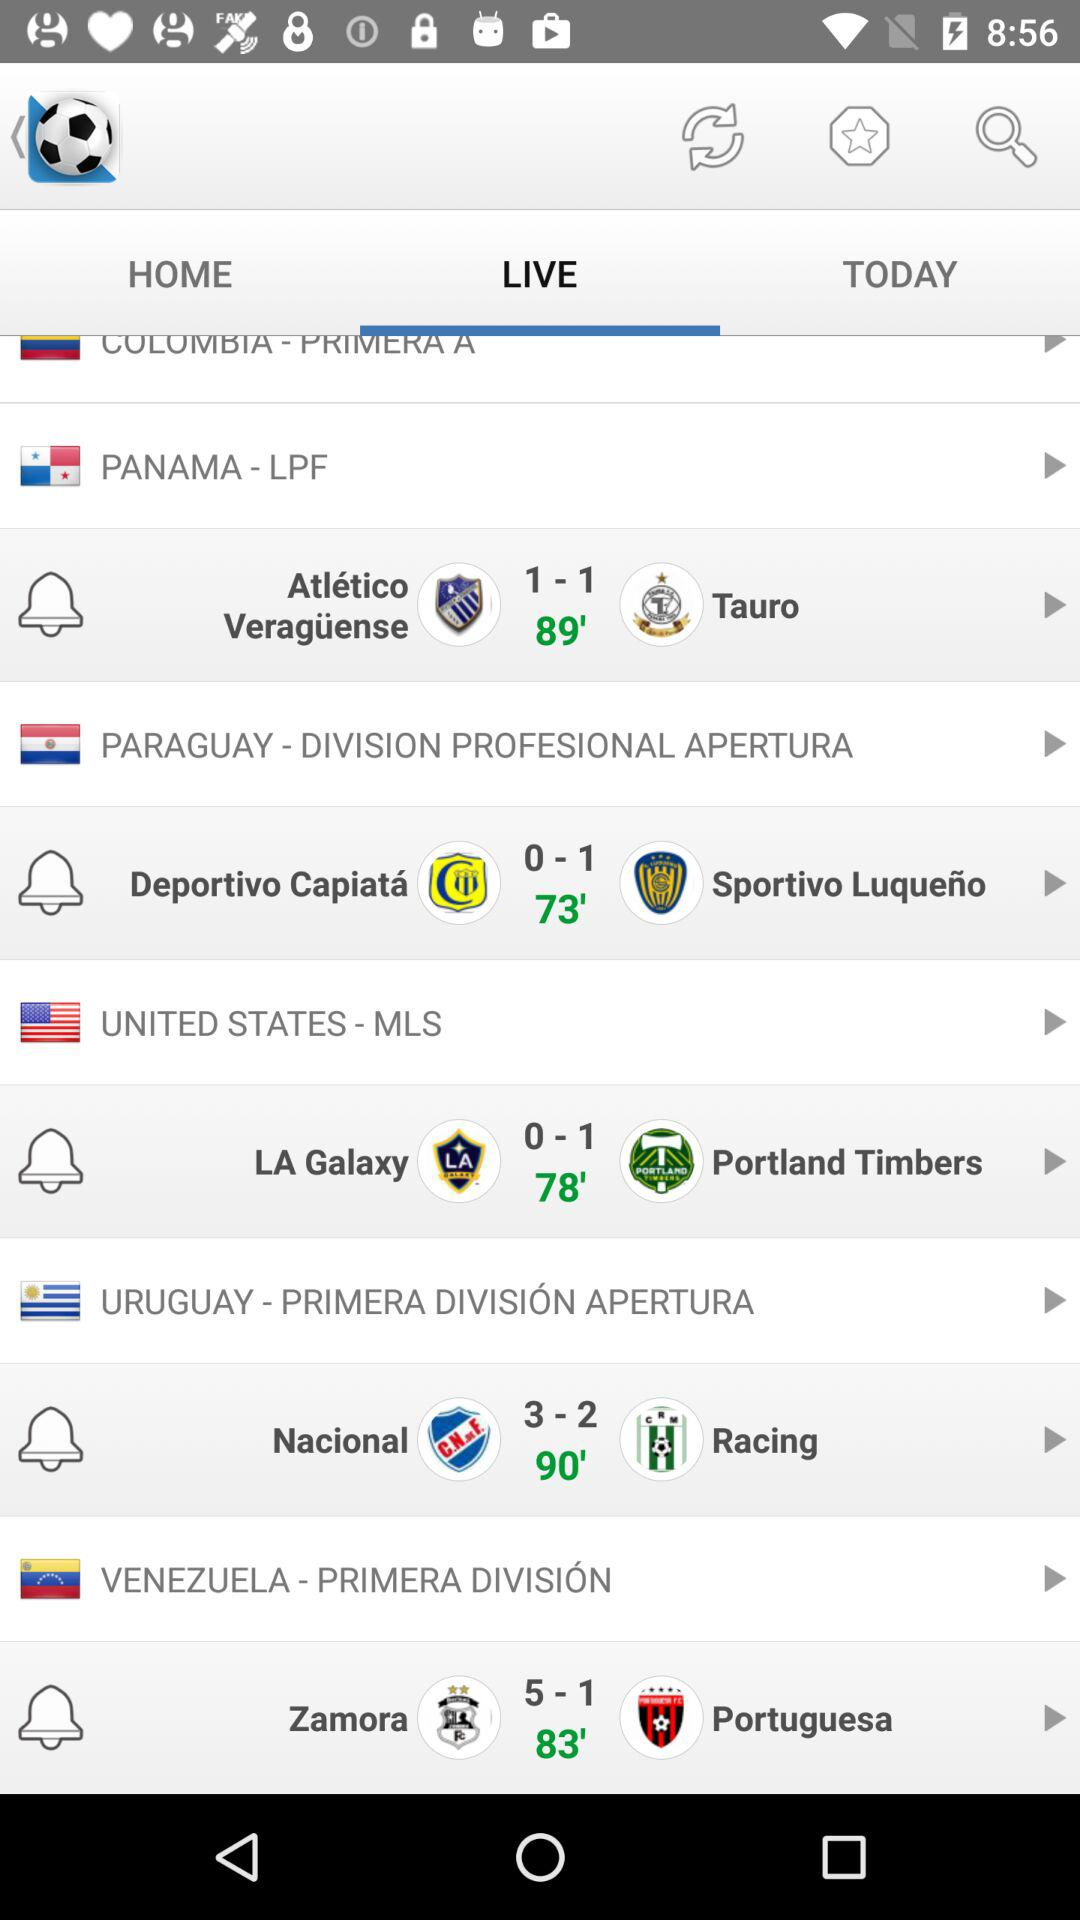Which tab am I using? You are using "LIVE" tab. 